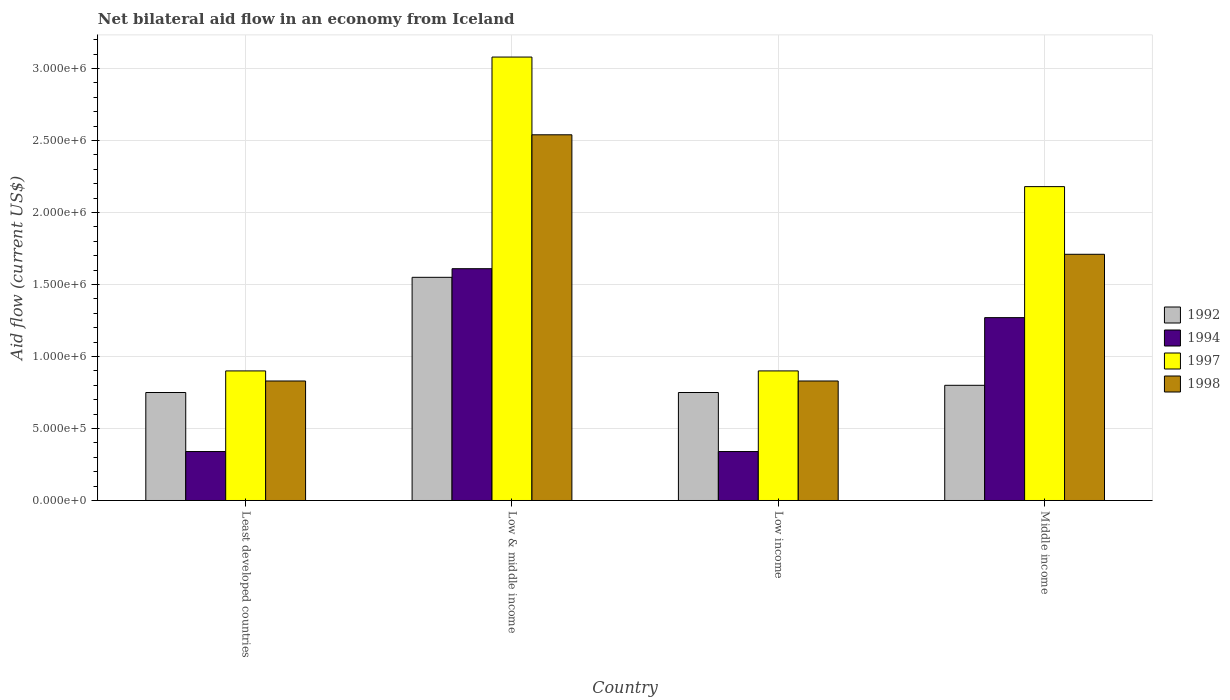How many groups of bars are there?
Give a very brief answer. 4. How many bars are there on the 1st tick from the right?
Give a very brief answer. 4. What is the label of the 1st group of bars from the left?
Keep it short and to the point. Least developed countries. In how many cases, is the number of bars for a given country not equal to the number of legend labels?
Your answer should be compact. 0. Across all countries, what is the maximum net bilateral aid flow in 1994?
Your response must be concise. 1.61e+06. Across all countries, what is the minimum net bilateral aid flow in 1998?
Provide a short and direct response. 8.30e+05. In which country was the net bilateral aid flow in 1992 minimum?
Ensure brevity in your answer.  Least developed countries. What is the total net bilateral aid flow in 1994 in the graph?
Offer a terse response. 3.56e+06. What is the difference between the net bilateral aid flow in 1992 in Low income and that in Middle income?
Your answer should be compact. -5.00e+04. What is the difference between the net bilateral aid flow in 1994 in Low & middle income and the net bilateral aid flow in 1998 in Least developed countries?
Offer a terse response. 7.80e+05. What is the average net bilateral aid flow in 1998 per country?
Make the answer very short. 1.48e+06. What is the difference between the net bilateral aid flow of/in 1992 and net bilateral aid flow of/in 1994 in Middle income?
Offer a terse response. -4.70e+05. What is the ratio of the net bilateral aid flow in 1992 in Low & middle income to that in Low income?
Ensure brevity in your answer.  2.07. Is the difference between the net bilateral aid flow in 1992 in Low & middle income and Low income greater than the difference between the net bilateral aid flow in 1994 in Low & middle income and Low income?
Your response must be concise. No. What is the difference between the highest and the second highest net bilateral aid flow in 1994?
Make the answer very short. 3.40e+05. What is the difference between the highest and the lowest net bilateral aid flow in 1997?
Your answer should be very brief. 2.18e+06. Is it the case that in every country, the sum of the net bilateral aid flow in 1992 and net bilateral aid flow in 1994 is greater than the sum of net bilateral aid flow in 1998 and net bilateral aid flow in 1997?
Ensure brevity in your answer.  No. What does the 2nd bar from the left in Low income represents?
Your response must be concise. 1994. How many bars are there?
Offer a very short reply. 16. Are all the bars in the graph horizontal?
Offer a very short reply. No. How many countries are there in the graph?
Provide a short and direct response. 4. What is the difference between two consecutive major ticks on the Y-axis?
Your answer should be compact. 5.00e+05. Does the graph contain any zero values?
Your answer should be compact. No. Does the graph contain grids?
Your answer should be very brief. Yes. What is the title of the graph?
Your response must be concise. Net bilateral aid flow in an economy from Iceland. What is the label or title of the X-axis?
Offer a terse response. Country. What is the label or title of the Y-axis?
Offer a terse response. Aid flow (current US$). What is the Aid flow (current US$) of 1992 in Least developed countries?
Give a very brief answer. 7.50e+05. What is the Aid flow (current US$) of 1994 in Least developed countries?
Your answer should be compact. 3.40e+05. What is the Aid flow (current US$) in 1997 in Least developed countries?
Your response must be concise. 9.00e+05. What is the Aid flow (current US$) in 1998 in Least developed countries?
Provide a short and direct response. 8.30e+05. What is the Aid flow (current US$) of 1992 in Low & middle income?
Your answer should be very brief. 1.55e+06. What is the Aid flow (current US$) in 1994 in Low & middle income?
Offer a terse response. 1.61e+06. What is the Aid flow (current US$) in 1997 in Low & middle income?
Your response must be concise. 3.08e+06. What is the Aid flow (current US$) of 1998 in Low & middle income?
Make the answer very short. 2.54e+06. What is the Aid flow (current US$) in 1992 in Low income?
Your answer should be compact. 7.50e+05. What is the Aid flow (current US$) of 1994 in Low income?
Provide a short and direct response. 3.40e+05. What is the Aid flow (current US$) in 1998 in Low income?
Your response must be concise. 8.30e+05. What is the Aid flow (current US$) of 1994 in Middle income?
Your answer should be compact. 1.27e+06. What is the Aid flow (current US$) in 1997 in Middle income?
Offer a terse response. 2.18e+06. What is the Aid flow (current US$) of 1998 in Middle income?
Ensure brevity in your answer.  1.71e+06. Across all countries, what is the maximum Aid flow (current US$) in 1992?
Provide a succinct answer. 1.55e+06. Across all countries, what is the maximum Aid flow (current US$) of 1994?
Give a very brief answer. 1.61e+06. Across all countries, what is the maximum Aid flow (current US$) of 1997?
Offer a very short reply. 3.08e+06. Across all countries, what is the maximum Aid flow (current US$) of 1998?
Offer a terse response. 2.54e+06. Across all countries, what is the minimum Aid flow (current US$) of 1992?
Your answer should be very brief. 7.50e+05. Across all countries, what is the minimum Aid flow (current US$) of 1994?
Provide a succinct answer. 3.40e+05. Across all countries, what is the minimum Aid flow (current US$) of 1998?
Provide a succinct answer. 8.30e+05. What is the total Aid flow (current US$) in 1992 in the graph?
Make the answer very short. 3.85e+06. What is the total Aid flow (current US$) of 1994 in the graph?
Keep it short and to the point. 3.56e+06. What is the total Aid flow (current US$) of 1997 in the graph?
Your answer should be compact. 7.06e+06. What is the total Aid flow (current US$) in 1998 in the graph?
Ensure brevity in your answer.  5.91e+06. What is the difference between the Aid flow (current US$) in 1992 in Least developed countries and that in Low & middle income?
Offer a very short reply. -8.00e+05. What is the difference between the Aid flow (current US$) of 1994 in Least developed countries and that in Low & middle income?
Keep it short and to the point. -1.27e+06. What is the difference between the Aid flow (current US$) of 1997 in Least developed countries and that in Low & middle income?
Your response must be concise. -2.18e+06. What is the difference between the Aid flow (current US$) of 1998 in Least developed countries and that in Low & middle income?
Provide a succinct answer. -1.71e+06. What is the difference between the Aid flow (current US$) in 1994 in Least developed countries and that in Low income?
Make the answer very short. 0. What is the difference between the Aid flow (current US$) of 1992 in Least developed countries and that in Middle income?
Provide a short and direct response. -5.00e+04. What is the difference between the Aid flow (current US$) of 1994 in Least developed countries and that in Middle income?
Give a very brief answer. -9.30e+05. What is the difference between the Aid flow (current US$) of 1997 in Least developed countries and that in Middle income?
Keep it short and to the point. -1.28e+06. What is the difference between the Aid flow (current US$) of 1998 in Least developed countries and that in Middle income?
Provide a succinct answer. -8.80e+05. What is the difference between the Aid flow (current US$) in 1992 in Low & middle income and that in Low income?
Provide a short and direct response. 8.00e+05. What is the difference between the Aid flow (current US$) in 1994 in Low & middle income and that in Low income?
Your answer should be compact. 1.27e+06. What is the difference between the Aid flow (current US$) of 1997 in Low & middle income and that in Low income?
Ensure brevity in your answer.  2.18e+06. What is the difference between the Aid flow (current US$) in 1998 in Low & middle income and that in Low income?
Your answer should be compact. 1.71e+06. What is the difference between the Aid flow (current US$) of 1992 in Low & middle income and that in Middle income?
Provide a succinct answer. 7.50e+05. What is the difference between the Aid flow (current US$) of 1998 in Low & middle income and that in Middle income?
Your answer should be very brief. 8.30e+05. What is the difference between the Aid flow (current US$) in 1992 in Low income and that in Middle income?
Give a very brief answer. -5.00e+04. What is the difference between the Aid flow (current US$) in 1994 in Low income and that in Middle income?
Your answer should be very brief. -9.30e+05. What is the difference between the Aid flow (current US$) in 1997 in Low income and that in Middle income?
Ensure brevity in your answer.  -1.28e+06. What is the difference between the Aid flow (current US$) in 1998 in Low income and that in Middle income?
Offer a very short reply. -8.80e+05. What is the difference between the Aid flow (current US$) in 1992 in Least developed countries and the Aid flow (current US$) in 1994 in Low & middle income?
Give a very brief answer. -8.60e+05. What is the difference between the Aid flow (current US$) of 1992 in Least developed countries and the Aid flow (current US$) of 1997 in Low & middle income?
Your answer should be very brief. -2.33e+06. What is the difference between the Aid flow (current US$) in 1992 in Least developed countries and the Aid flow (current US$) in 1998 in Low & middle income?
Provide a short and direct response. -1.79e+06. What is the difference between the Aid flow (current US$) in 1994 in Least developed countries and the Aid flow (current US$) in 1997 in Low & middle income?
Provide a succinct answer. -2.74e+06. What is the difference between the Aid flow (current US$) in 1994 in Least developed countries and the Aid flow (current US$) in 1998 in Low & middle income?
Provide a succinct answer. -2.20e+06. What is the difference between the Aid flow (current US$) in 1997 in Least developed countries and the Aid flow (current US$) in 1998 in Low & middle income?
Give a very brief answer. -1.64e+06. What is the difference between the Aid flow (current US$) of 1992 in Least developed countries and the Aid flow (current US$) of 1997 in Low income?
Make the answer very short. -1.50e+05. What is the difference between the Aid flow (current US$) in 1994 in Least developed countries and the Aid flow (current US$) in 1997 in Low income?
Your answer should be very brief. -5.60e+05. What is the difference between the Aid flow (current US$) in 1994 in Least developed countries and the Aid flow (current US$) in 1998 in Low income?
Your answer should be compact. -4.90e+05. What is the difference between the Aid flow (current US$) of 1992 in Least developed countries and the Aid flow (current US$) of 1994 in Middle income?
Keep it short and to the point. -5.20e+05. What is the difference between the Aid flow (current US$) in 1992 in Least developed countries and the Aid flow (current US$) in 1997 in Middle income?
Ensure brevity in your answer.  -1.43e+06. What is the difference between the Aid flow (current US$) in 1992 in Least developed countries and the Aid flow (current US$) in 1998 in Middle income?
Your answer should be very brief. -9.60e+05. What is the difference between the Aid flow (current US$) in 1994 in Least developed countries and the Aid flow (current US$) in 1997 in Middle income?
Provide a short and direct response. -1.84e+06. What is the difference between the Aid flow (current US$) of 1994 in Least developed countries and the Aid flow (current US$) of 1998 in Middle income?
Offer a terse response. -1.37e+06. What is the difference between the Aid flow (current US$) of 1997 in Least developed countries and the Aid flow (current US$) of 1998 in Middle income?
Give a very brief answer. -8.10e+05. What is the difference between the Aid flow (current US$) in 1992 in Low & middle income and the Aid flow (current US$) in 1994 in Low income?
Your answer should be compact. 1.21e+06. What is the difference between the Aid flow (current US$) in 1992 in Low & middle income and the Aid flow (current US$) in 1997 in Low income?
Keep it short and to the point. 6.50e+05. What is the difference between the Aid flow (current US$) of 1992 in Low & middle income and the Aid flow (current US$) of 1998 in Low income?
Make the answer very short. 7.20e+05. What is the difference between the Aid flow (current US$) of 1994 in Low & middle income and the Aid flow (current US$) of 1997 in Low income?
Give a very brief answer. 7.10e+05. What is the difference between the Aid flow (current US$) in 1994 in Low & middle income and the Aid flow (current US$) in 1998 in Low income?
Give a very brief answer. 7.80e+05. What is the difference between the Aid flow (current US$) in 1997 in Low & middle income and the Aid flow (current US$) in 1998 in Low income?
Offer a terse response. 2.25e+06. What is the difference between the Aid flow (current US$) in 1992 in Low & middle income and the Aid flow (current US$) in 1994 in Middle income?
Offer a very short reply. 2.80e+05. What is the difference between the Aid flow (current US$) of 1992 in Low & middle income and the Aid flow (current US$) of 1997 in Middle income?
Make the answer very short. -6.30e+05. What is the difference between the Aid flow (current US$) in 1994 in Low & middle income and the Aid flow (current US$) in 1997 in Middle income?
Provide a succinct answer. -5.70e+05. What is the difference between the Aid flow (current US$) in 1994 in Low & middle income and the Aid flow (current US$) in 1998 in Middle income?
Your answer should be very brief. -1.00e+05. What is the difference between the Aid flow (current US$) in 1997 in Low & middle income and the Aid flow (current US$) in 1998 in Middle income?
Give a very brief answer. 1.37e+06. What is the difference between the Aid flow (current US$) in 1992 in Low income and the Aid flow (current US$) in 1994 in Middle income?
Offer a terse response. -5.20e+05. What is the difference between the Aid flow (current US$) of 1992 in Low income and the Aid flow (current US$) of 1997 in Middle income?
Keep it short and to the point. -1.43e+06. What is the difference between the Aid flow (current US$) in 1992 in Low income and the Aid flow (current US$) in 1998 in Middle income?
Provide a short and direct response. -9.60e+05. What is the difference between the Aid flow (current US$) of 1994 in Low income and the Aid flow (current US$) of 1997 in Middle income?
Keep it short and to the point. -1.84e+06. What is the difference between the Aid flow (current US$) in 1994 in Low income and the Aid flow (current US$) in 1998 in Middle income?
Your response must be concise. -1.37e+06. What is the difference between the Aid flow (current US$) in 1997 in Low income and the Aid flow (current US$) in 1998 in Middle income?
Your response must be concise. -8.10e+05. What is the average Aid flow (current US$) of 1992 per country?
Provide a short and direct response. 9.62e+05. What is the average Aid flow (current US$) of 1994 per country?
Offer a terse response. 8.90e+05. What is the average Aid flow (current US$) in 1997 per country?
Your response must be concise. 1.76e+06. What is the average Aid flow (current US$) in 1998 per country?
Provide a short and direct response. 1.48e+06. What is the difference between the Aid flow (current US$) in 1992 and Aid flow (current US$) in 1994 in Least developed countries?
Ensure brevity in your answer.  4.10e+05. What is the difference between the Aid flow (current US$) in 1992 and Aid flow (current US$) in 1998 in Least developed countries?
Keep it short and to the point. -8.00e+04. What is the difference between the Aid flow (current US$) in 1994 and Aid flow (current US$) in 1997 in Least developed countries?
Offer a terse response. -5.60e+05. What is the difference between the Aid flow (current US$) of 1994 and Aid flow (current US$) of 1998 in Least developed countries?
Offer a very short reply. -4.90e+05. What is the difference between the Aid flow (current US$) in 1992 and Aid flow (current US$) in 1997 in Low & middle income?
Your answer should be very brief. -1.53e+06. What is the difference between the Aid flow (current US$) in 1992 and Aid flow (current US$) in 1998 in Low & middle income?
Offer a terse response. -9.90e+05. What is the difference between the Aid flow (current US$) of 1994 and Aid flow (current US$) of 1997 in Low & middle income?
Provide a short and direct response. -1.47e+06. What is the difference between the Aid flow (current US$) in 1994 and Aid flow (current US$) in 1998 in Low & middle income?
Keep it short and to the point. -9.30e+05. What is the difference between the Aid flow (current US$) in 1997 and Aid flow (current US$) in 1998 in Low & middle income?
Ensure brevity in your answer.  5.40e+05. What is the difference between the Aid flow (current US$) in 1992 and Aid flow (current US$) in 1994 in Low income?
Offer a very short reply. 4.10e+05. What is the difference between the Aid flow (current US$) in 1994 and Aid flow (current US$) in 1997 in Low income?
Your answer should be very brief. -5.60e+05. What is the difference between the Aid flow (current US$) of 1994 and Aid flow (current US$) of 1998 in Low income?
Your answer should be very brief. -4.90e+05. What is the difference between the Aid flow (current US$) in 1997 and Aid flow (current US$) in 1998 in Low income?
Ensure brevity in your answer.  7.00e+04. What is the difference between the Aid flow (current US$) in 1992 and Aid flow (current US$) in 1994 in Middle income?
Provide a succinct answer. -4.70e+05. What is the difference between the Aid flow (current US$) of 1992 and Aid flow (current US$) of 1997 in Middle income?
Your answer should be compact. -1.38e+06. What is the difference between the Aid flow (current US$) of 1992 and Aid flow (current US$) of 1998 in Middle income?
Your response must be concise. -9.10e+05. What is the difference between the Aid flow (current US$) in 1994 and Aid flow (current US$) in 1997 in Middle income?
Provide a short and direct response. -9.10e+05. What is the difference between the Aid flow (current US$) of 1994 and Aid flow (current US$) of 1998 in Middle income?
Your response must be concise. -4.40e+05. What is the ratio of the Aid flow (current US$) of 1992 in Least developed countries to that in Low & middle income?
Give a very brief answer. 0.48. What is the ratio of the Aid flow (current US$) of 1994 in Least developed countries to that in Low & middle income?
Ensure brevity in your answer.  0.21. What is the ratio of the Aid flow (current US$) in 1997 in Least developed countries to that in Low & middle income?
Keep it short and to the point. 0.29. What is the ratio of the Aid flow (current US$) in 1998 in Least developed countries to that in Low & middle income?
Provide a succinct answer. 0.33. What is the ratio of the Aid flow (current US$) of 1992 in Least developed countries to that in Low income?
Make the answer very short. 1. What is the ratio of the Aid flow (current US$) of 1994 in Least developed countries to that in Low income?
Give a very brief answer. 1. What is the ratio of the Aid flow (current US$) in 1997 in Least developed countries to that in Low income?
Give a very brief answer. 1. What is the ratio of the Aid flow (current US$) of 1992 in Least developed countries to that in Middle income?
Your answer should be compact. 0.94. What is the ratio of the Aid flow (current US$) of 1994 in Least developed countries to that in Middle income?
Your answer should be compact. 0.27. What is the ratio of the Aid flow (current US$) of 1997 in Least developed countries to that in Middle income?
Your answer should be compact. 0.41. What is the ratio of the Aid flow (current US$) in 1998 in Least developed countries to that in Middle income?
Your response must be concise. 0.49. What is the ratio of the Aid flow (current US$) in 1992 in Low & middle income to that in Low income?
Provide a succinct answer. 2.07. What is the ratio of the Aid flow (current US$) of 1994 in Low & middle income to that in Low income?
Provide a short and direct response. 4.74. What is the ratio of the Aid flow (current US$) in 1997 in Low & middle income to that in Low income?
Provide a succinct answer. 3.42. What is the ratio of the Aid flow (current US$) of 1998 in Low & middle income to that in Low income?
Ensure brevity in your answer.  3.06. What is the ratio of the Aid flow (current US$) of 1992 in Low & middle income to that in Middle income?
Provide a succinct answer. 1.94. What is the ratio of the Aid flow (current US$) in 1994 in Low & middle income to that in Middle income?
Give a very brief answer. 1.27. What is the ratio of the Aid flow (current US$) in 1997 in Low & middle income to that in Middle income?
Offer a terse response. 1.41. What is the ratio of the Aid flow (current US$) in 1998 in Low & middle income to that in Middle income?
Provide a short and direct response. 1.49. What is the ratio of the Aid flow (current US$) in 1992 in Low income to that in Middle income?
Keep it short and to the point. 0.94. What is the ratio of the Aid flow (current US$) of 1994 in Low income to that in Middle income?
Give a very brief answer. 0.27. What is the ratio of the Aid flow (current US$) in 1997 in Low income to that in Middle income?
Provide a short and direct response. 0.41. What is the ratio of the Aid flow (current US$) of 1998 in Low income to that in Middle income?
Provide a succinct answer. 0.49. What is the difference between the highest and the second highest Aid flow (current US$) of 1992?
Make the answer very short. 7.50e+05. What is the difference between the highest and the second highest Aid flow (current US$) of 1994?
Your response must be concise. 3.40e+05. What is the difference between the highest and the second highest Aid flow (current US$) of 1997?
Give a very brief answer. 9.00e+05. What is the difference between the highest and the second highest Aid flow (current US$) of 1998?
Offer a very short reply. 8.30e+05. What is the difference between the highest and the lowest Aid flow (current US$) in 1994?
Offer a very short reply. 1.27e+06. What is the difference between the highest and the lowest Aid flow (current US$) of 1997?
Offer a terse response. 2.18e+06. What is the difference between the highest and the lowest Aid flow (current US$) in 1998?
Keep it short and to the point. 1.71e+06. 